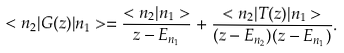Convert formula to latex. <formula><loc_0><loc_0><loc_500><loc_500>< n _ { 2 } | G ( z ) | n _ { 1 } > = \frac { < n _ { 2 } | n _ { 1 } > } { z - E _ { n _ { 1 } } } + \frac { < n _ { 2 } | T ( z ) | n _ { 1 } > } { ( z - E _ { n _ { 2 } } ) ( z - E _ { n _ { 1 } } ) } .</formula> 